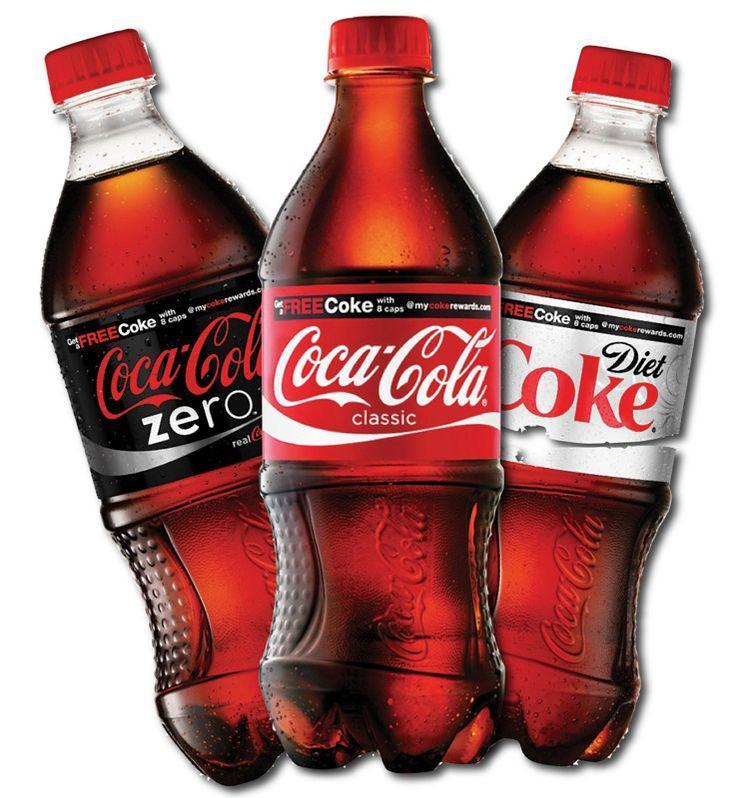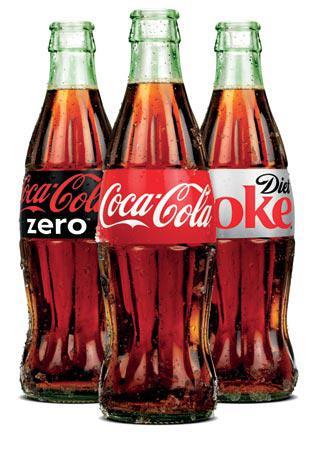The first image is the image on the left, the second image is the image on the right. Considering the images on both sides, is "There are no more than four bottles of soda." valid? Answer yes or no. No. The first image is the image on the left, the second image is the image on the right. Examine the images to the left and right. Is the description "There is only one bottle in one of the images." accurate? Answer yes or no. No. 